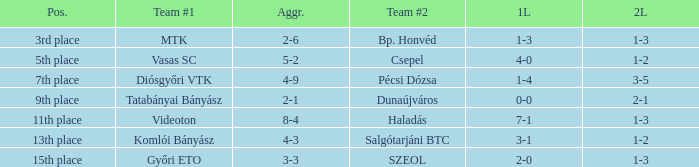What is the 1st leg of bp. honvéd team #2? 1-3. 